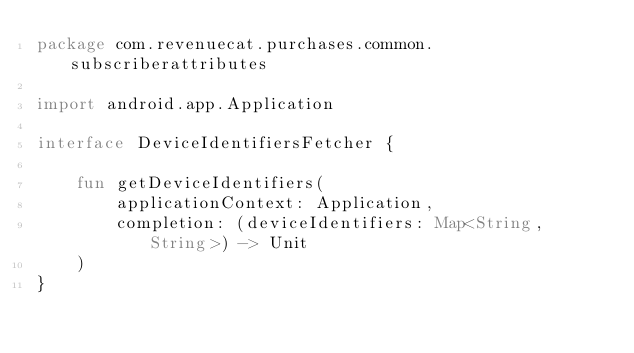Convert code to text. <code><loc_0><loc_0><loc_500><loc_500><_Kotlin_>package com.revenuecat.purchases.common.subscriberattributes

import android.app.Application

interface DeviceIdentifiersFetcher {

    fun getDeviceIdentifiers(
        applicationContext: Application,
        completion: (deviceIdentifiers: Map<String, String>) -> Unit
    )
}
</code> 